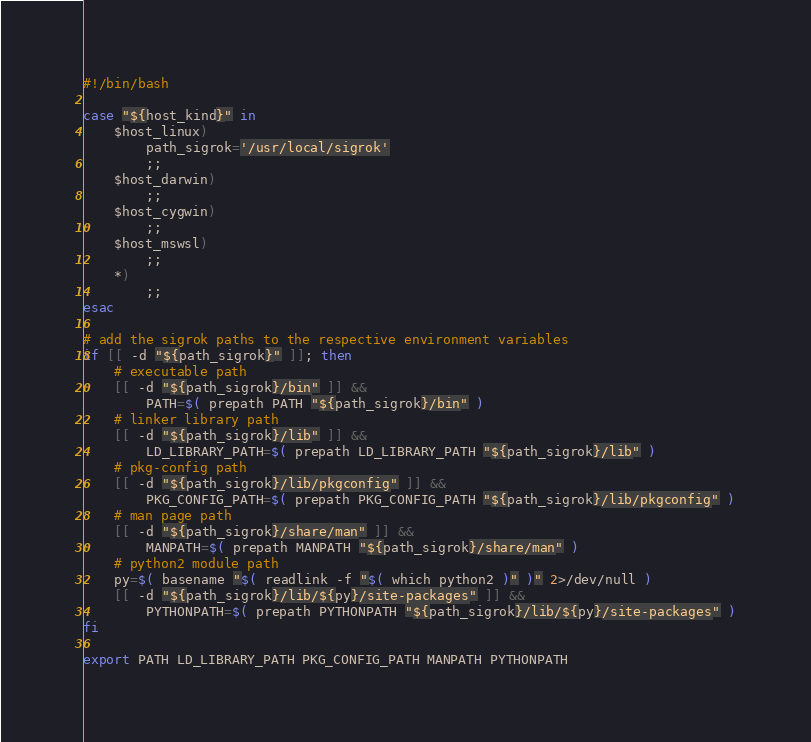<code> <loc_0><loc_0><loc_500><loc_500><_Bash_>#!/bin/bash

case "${host_kind}" in
	$host_linux)
		path_sigrok='/usr/local/sigrok'
		;;
	$host_darwin)
		;;
	$host_cygwin)
		;;
	$host_mswsl)
		;;
	*)
		;;
esac

# add the sigrok paths to the respective environment variables
if [[ -d "${path_sigrok}" ]]; then
	# executable path
	[[ -d "${path_sigrok}/bin" ]] && 
		PATH=$( prepath PATH "${path_sigrok}/bin" )
	# linker library path
	[[ -d "${path_sigrok}/lib" ]] && 
		LD_LIBRARY_PATH=$( prepath LD_LIBRARY_PATH "${path_sigrok}/lib" )
	# pkg-config path
	[[ -d "${path_sigrok}/lib/pkgconfig" ]] && 
		PKG_CONFIG_PATH=$( prepath PKG_CONFIG_PATH "${path_sigrok}/lib/pkgconfig" )
	# man page path
	[[ -d "${path_sigrok}/share/man" ]] && 
		MANPATH=$( prepath MANPATH "${path_sigrok}/share/man" )
	# python2 module path
	py=$( basename "$( readlink -f "$( which python2 )" )" 2>/dev/null )
	[[ -d "${path_sigrok}/lib/${py}/site-packages" ]] && 
		PYTHONPATH=$( prepath PYTHONPATH "${path_sigrok}/lib/${py}/site-packages" )
fi

export PATH LD_LIBRARY_PATH PKG_CONFIG_PATH MANPATH PYTHONPATH
</code> 